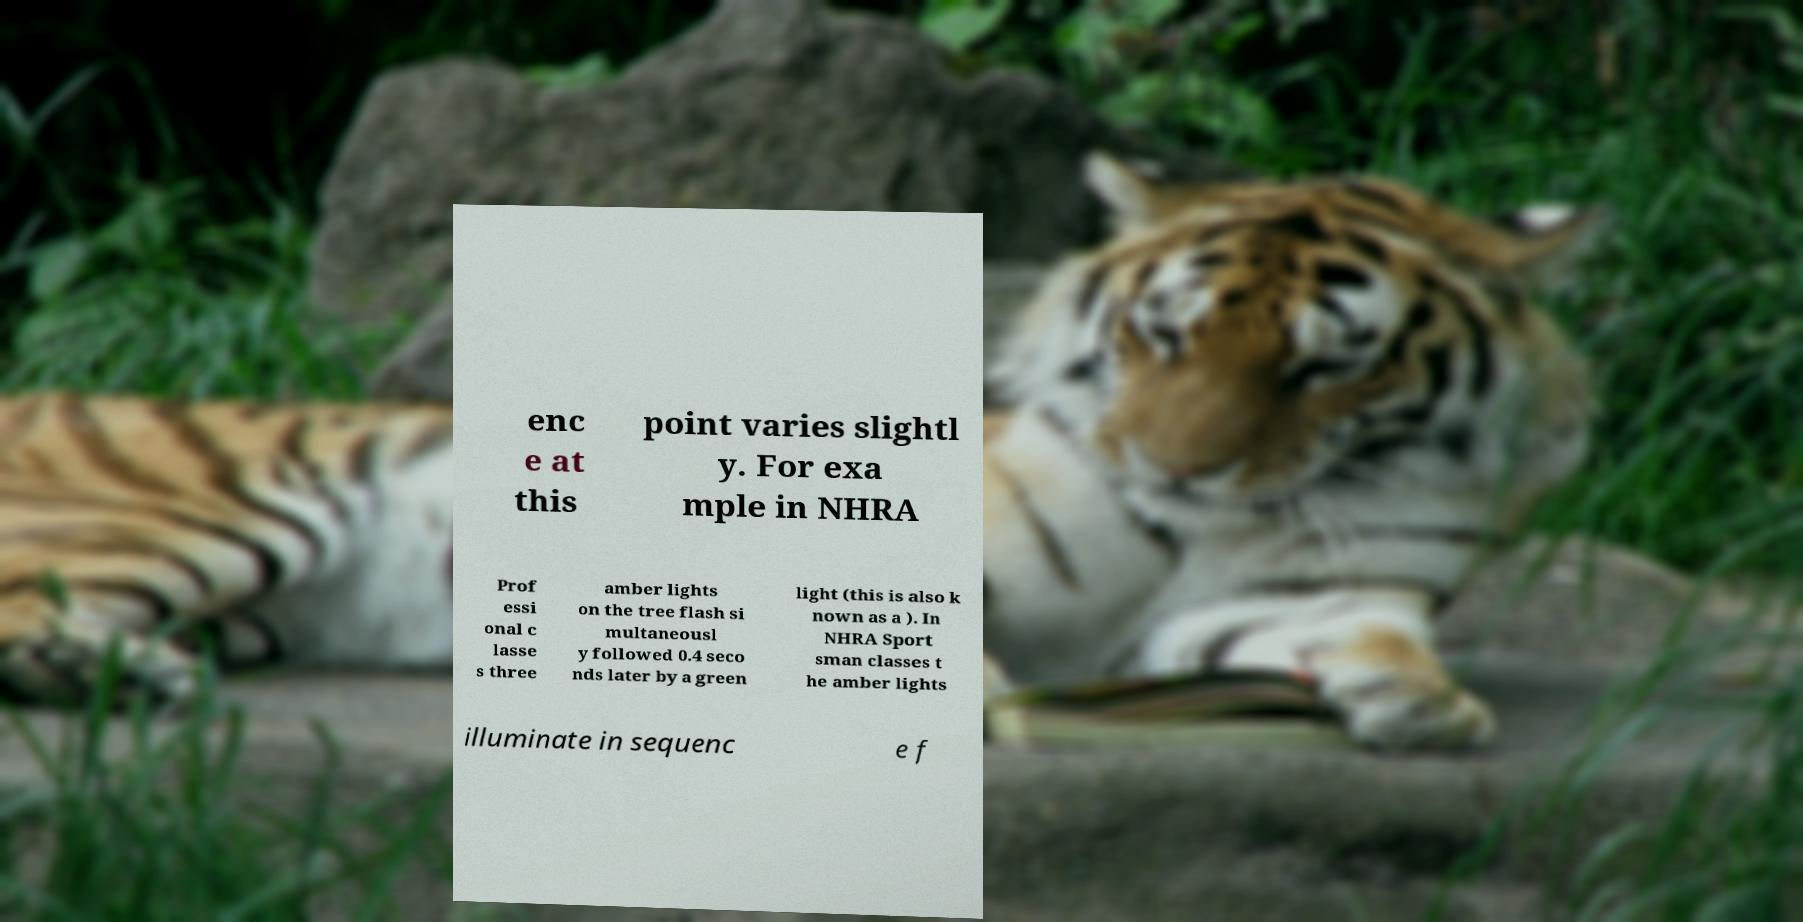There's text embedded in this image that I need extracted. Can you transcribe it verbatim? enc e at this point varies slightl y. For exa mple in NHRA Prof essi onal c lasse s three amber lights on the tree flash si multaneousl y followed 0.4 seco nds later by a green light (this is also k nown as a ). In NHRA Sport sman classes t he amber lights illuminate in sequenc e f 